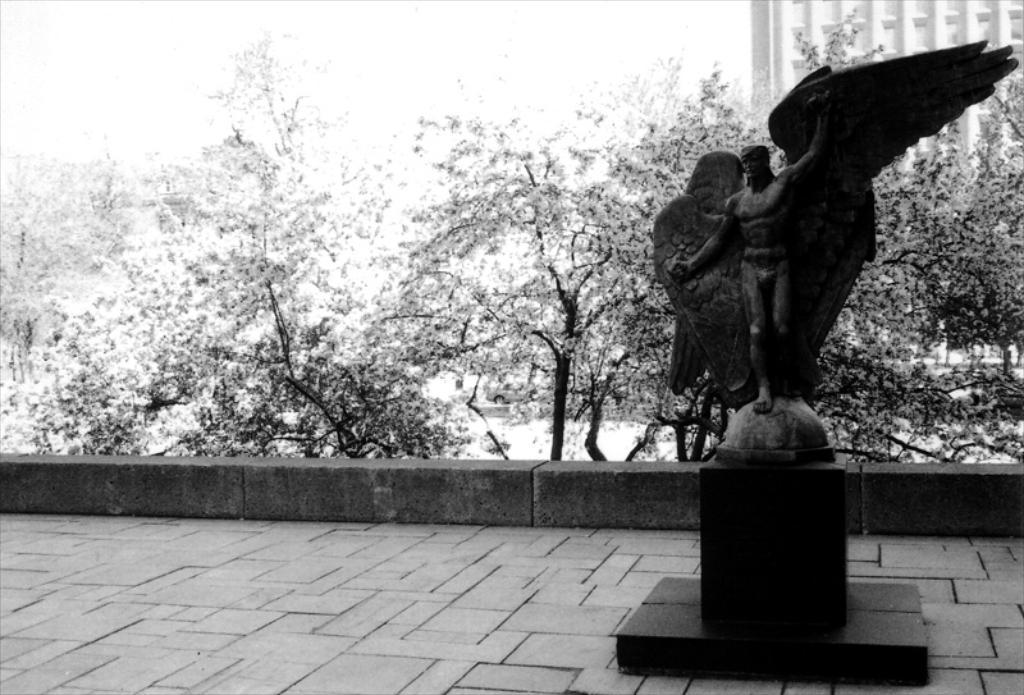How would you summarize this image in a sentence or two? To the right side there is a statue of man with wings. He is standing. To the bottom there is a footpath. In the background there are trees and to the right side top corner there is a building. 